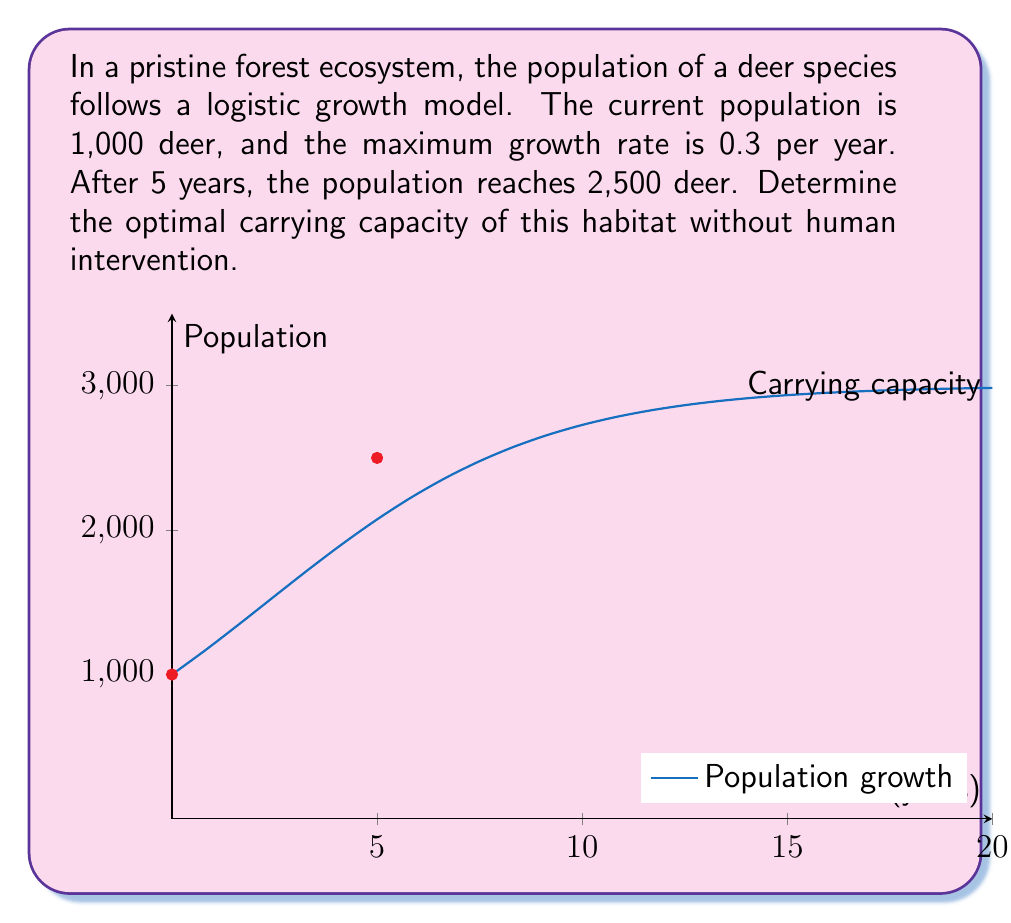Can you solve this math problem? Let's approach this step-by-step using the logistic growth model:

1) The logistic growth model is given by:
   $$P(t) = \frac{K}{1 + (\frac{K}{P_0} - 1)e^{-rt}}$$
   where $K$ is the carrying capacity, $P_0$ is the initial population, $r$ is the growth rate, and $t$ is time.

2) We know:
   $P_0 = 1000$
   $r = 0.3$
   $t = 5$ (when population reaches 2500)
   $P(5) = 2500$

3) Substituting these values into the equation:
   $$2500 = \frac{K}{1 + (\frac{K}{1000} - 1)e^{-0.3 * 5}}$$

4) Simplify:
   $$2500 = \frac{K}{1 + (\frac{K}{1000} - 1)e^{-1.5}}$$

5) Let $a = e^{-1.5} \approx 0.2231$
   $$2500 = \frac{K}{1 + (\frac{K}{1000} - 1)a}$$

6) Cross-multiply:
   $$2500 + 2500(\frac{K}{1000} - 1)a = K$$

7) Expand:
   $$2500 + 2.5Ka - 2500a = K$$

8) Rearrange:
   $$2500(1-a) = K(1 - 2.5a)$$

9) Solve for K:
   $$K = \frac{2500(1-a)}{1 - 2.5a} \approx 3000$$

The carrying capacity is approximately 3,000 deer, which represents the optimal population the habitat can sustain without human intervention.
Answer: $K \approx 3000$ deer 